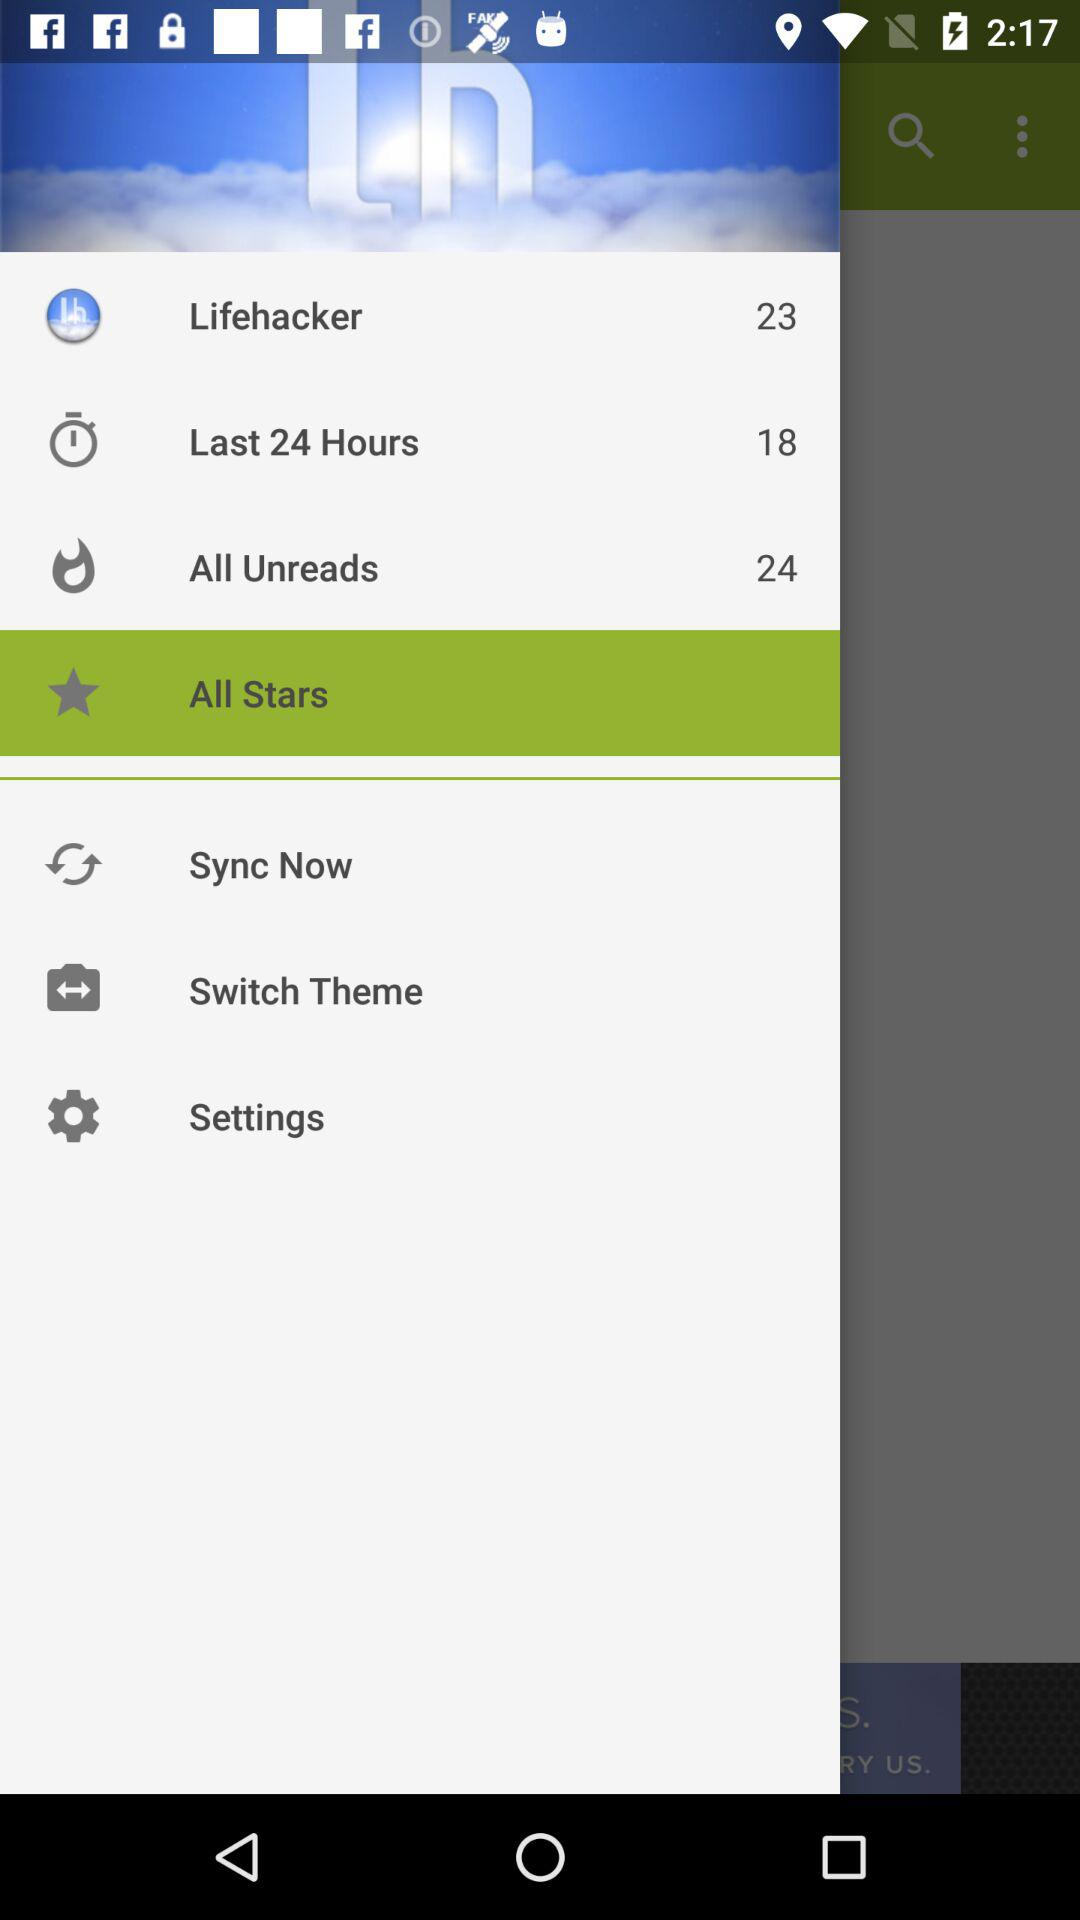Which option is selected? The selected option is "All Stars". 